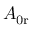<formula> <loc_0><loc_0><loc_500><loc_500>A _ { 0 r }</formula> 